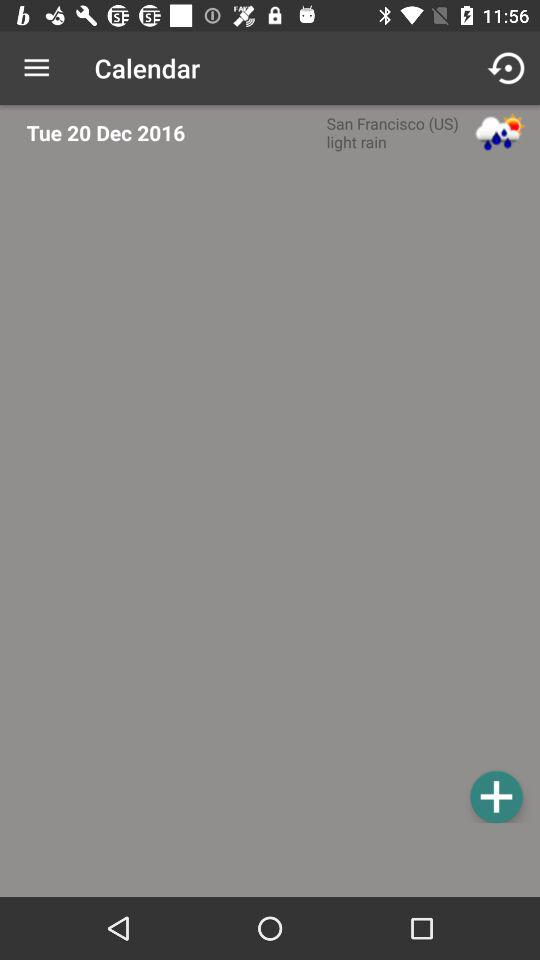What is the day on December 20? The day is Tuesday. 